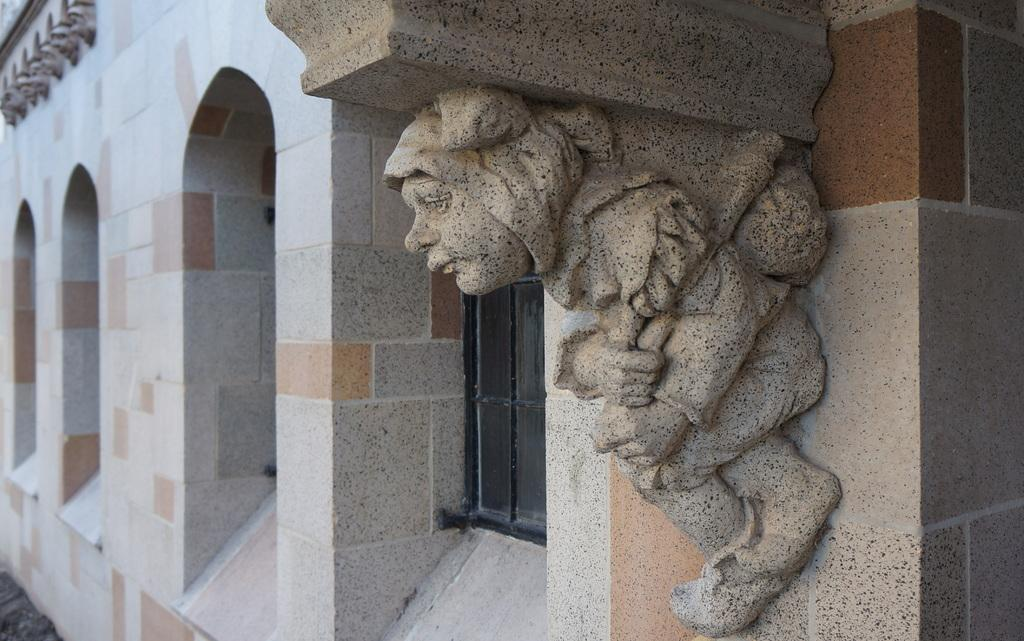What is on the wall in the image? There is a wall with windows and a carved object attached to it in the image. Can you describe the ground in the image? The ground is visible in the image. How many ears can be seen on the carved object in the image? There are no ears present on the carved object in the image, as it is not a living creature. 